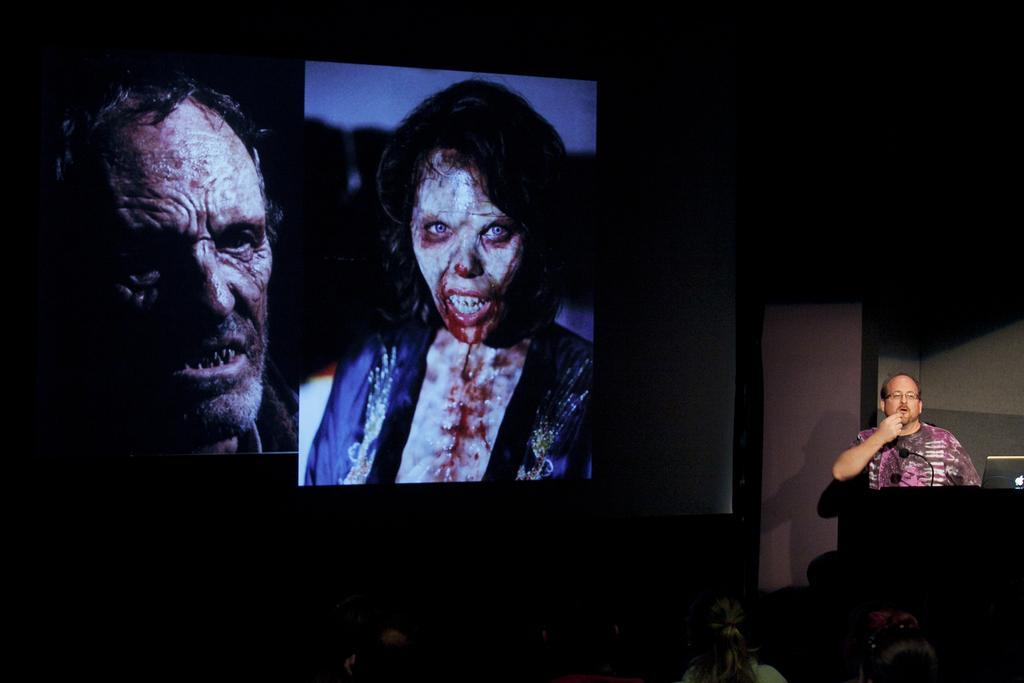Can you describe this image briefly? In this image I can see few people and the person is standing in front of the podium. I can also see the laptop and the mic. I can see two persons images on the screen. The image is dark. 